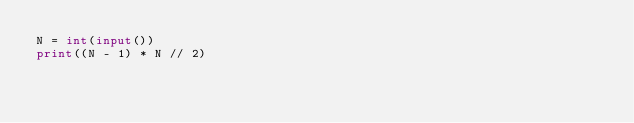<code> <loc_0><loc_0><loc_500><loc_500><_Python_>N = int(input())
print((N - 1) * N // 2)
</code> 